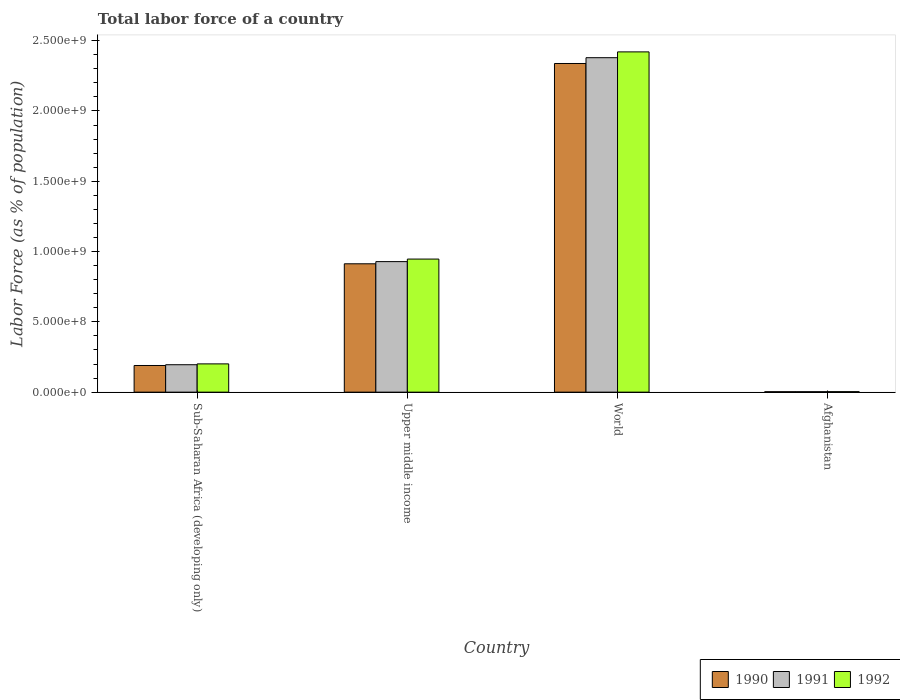How many groups of bars are there?
Make the answer very short. 4. Are the number of bars per tick equal to the number of legend labels?
Make the answer very short. Yes. Are the number of bars on each tick of the X-axis equal?
Provide a short and direct response. Yes. How many bars are there on the 2nd tick from the right?
Provide a succinct answer. 3. What is the label of the 2nd group of bars from the left?
Make the answer very short. Upper middle income. In how many cases, is the number of bars for a given country not equal to the number of legend labels?
Provide a succinct answer. 0. What is the percentage of labor force in 1991 in Upper middle income?
Provide a succinct answer. 9.28e+08. Across all countries, what is the maximum percentage of labor force in 1991?
Your response must be concise. 2.38e+09. Across all countries, what is the minimum percentage of labor force in 1992?
Offer a terse response. 3.50e+06. In which country was the percentage of labor force in 1992 minimum?
Provide a short and direct response. Afghanistan. What is the total percentage of labor force in 1991 in the graph?
Keep it short and to the point. 3.51e+09. What is the difference between the percentage of labor force in 1992 in Afghanistan and that in Upper middle income?
Your answer should be compact. -9.43e+08. What is the difference between the percentage of labor force in 1990 in Upper middle income and the percentage of labor force in 1991 in Afghanistan?
Offer a very short reply. 9.10e+08. What is the average percentage of labor force in 1990 per country?
Ensure brevity in your answer.  8.61e+08. What is the difference between the percentage of labor force of/in 1991 and percentage of labor force of/in 1992 in Upper middle income?
Your answer should be very brief. -1.81e+07. What is the ratio of the percentage of labor force in 1991 in Sub-Saharan Africa (developing only) to that in World?
Your answer should be compact. 0.08. Is the difference between the percentage of labor force in 1991 in Sub-Saharan Africa (developing only) and Upper middle income greater than the difference between the percentage of labor force in 1992 in Sub-Saharan Africa (developing only) and Upper middle income?
Provide a succinct answer. Yes. What is the difference between the highest and the second highest percentage of labor force in 1992?
Provide a succinct answer. 7.45e+08. What is the difference between the highest and the lowest percentage of labor force in 1992?
Your response must be concise. 2.42e+09. In how many countries, is the percentage of labor force in 1990 greater than the average percentage of labor force in 1990 taken over all countries?
Ensure brevity in your answer.  2. Is it the case that in every country, the sum of the percentage of labor force in 1991 and percentage of labor force in 1992 is greater than the percentage of labor force in 1990?
Provide a short and direct response. Yes. Are all the bars in the graph horizontal?
Your answer should be very brief. No. Are the values on the major ticks of Y-axis written in scientific E-notation?
Your response must be concise. Yes. Does the graph contain grids?
Offer a very short reply. No. What is the title of the graph?
Give a very brief answer. Total labor force of a country. What is the label or title of the Y-axis?
Your answer should be compact. Labor Force (as % of population). What is the Labor Force (as % of population) in 1990 in Sub-Saharan Africa (developing only)?
Your answer should be compact. 1.90e+08. What is the Labor Force (as % of population) in 1991 in Sub-Saharan Africa (developing only)?
Provide a short and direct response. 1.95e+08. What is the Labor Force (as % of population) in 1992 in Sub-Saharan Africa (developing only)?
Your response must be concise. 2.01e+08. What is the Labor Force (as % of population) in 1990 in Upper middle income?
Make the answer very short. 9.13e+08. What is the Labor Force (as % of population) in 1991 in Upper middle income?
Ensure brevity in your answer.  9.28e+08. What is the Labor Force (as % of population) in 1992 in Upper middle income?
Offer a terse response. 9.46e+08. What is the Labor Force (as % of population) of 1990 in World?
Your answer should be compact. 2.34e+09. What is the Labor Force (as % of population) in 1991 in World?
Your answer should be very brief. 2.38e+09. What is the Labor Force (as % of population) of 1992 in World?
Offer a very short reply. 2.42e+09. What is the Labor Force (as % of population) of 1990 in Afghanistan?
Keep it short and to the point. 3.08e+06. What is the Labor Force (as % of population) of 1991 in Afghanistan?
Offer a very short reply. 3.26e+06. What is the Labor Force (as % of population) of 1992 in Afghanistan?
Ensure brevity in your answer.  3.50e+06. Across all countries, what is the maximum Labor Force (as % of population) in 1990?
Your answer should be compact. 2.34e+09. Across all countries, what is the maximum Labor Force (as % of population) of 1991?
Keep it short and to the point. 2.38e+09. Across all countries, what is the maximum Labor Force (as % of population) in 1992?
Give a very brief answer. 2.42e+09. Across all countries, what is the minimum Labor Force (as % of population) of 1990?
Ensure brevity in your answer.  3.08e+06. Across all countries, what is the minimum Labor Force (as % of population) of 1991?
Make the answer very short. 3.26e+06. Across all countries, what is the minimum Labor Force (as % of population) of 1992?
Make the answer very short. 3.50e+06. What is the total Labor Force (as % of population) in 1990 in the graph?
Provide a succinct answer. 3.44e+09. What is the total Labor Force (as % of population) of 1991 in the graph?
Give a very brief answer. 3.51e+09. What is the total Labor Force (as % of population) of 1992 in the graph?
Make the answer very short. 3.57e+09. What is the difference between the Labor Force (as % of population) of 1990 in Sub-Saharan Africa (developing only) and that in Upper middle income?
Ensure brevity in your answer.  -7.23e+08. What is the difference between the Labor Force (as % of population) of 1991 in Sub-Saharan Africa (developing only) and that in Upper middle income?
Offer a very short reply. -7.33e+08. What is the difference between the Labor Force (as % of population) of 1992 in Sub-Saharan Africa (developing only) and that in Upper middle income?
Provide a short and direct response. -7.45e+08. What is the difference between the Labor Force (as % of population) in 1990 in Sub-Saharan Africa (developing only) and that in World?
Offer a terse response. -2.15e+09. What is the difference between the Labor Force (as % of population) of 1991 in Sub-Saharan Africa (developing only) and that in World?
Make the answer very short. -2.18e+09. What is the difference between the Labor Force (as % of population) of 1992 in Sub-Saharan Africa (developing only) and that in World?
Your answer should be compact. -2.22e+09. What is the difference between the Labor Force (as % of population) in 1990 in Sub-Saharan Africa (developing only) and that in Afghanistan?
Provide a short and direct response. 1.86e+08. What is the difference between the Labor Force (as % of population) in 1991 in Sub-Saharan Africa (developing only) and that in Afghanistan?
Your response must be concise. 1.92e+08. What is the difference between the Labor Force (as % of population) of 1992 in Sub-Saharan Africa (developing only) and that in Afghanistan?
Ensure brevity in your answer.  1.98e+08. What is the difference between the Labor Force (as % of population) in 1990 in Upper middle income and that in World?
Your response must be concise. -1.42e+09. What is the difference between the Labor Force (as % of population) in 1991 in Upper middle income and that in World?
Make the answer very short. -1.45e+09. What is the difference between the Labor Force (as % of population) in 1992 in Upper middle income and that in World?
Keep it short and to the point. -1.47e+09. What is the difference between the Labor Force (as % of population) of 1990 in Upper middle income and that in Afghanistan?
Provide a succinct answer. 9.10e+08. What is the difference between the Labor Force (as % of population) in 1991 in Upper middle income and that in Afghanistan?
Give a very brief answer. 9.25e+08. What is the difference between the Labor Force (as % of population) of 1992 in Upper middle income and that in Afghanistan?
Your answer should be compact. 9.43e+08. What is the difference between the Labor Force (as % of population) of 1990 in World and that in Afghanistan?
Provide a short and direct response. 2.33e+09. What is the difference between the Labor Force (as % of population) of 1991 in World and that in Afghanistan?
Ensure brevity in your answer.  2.38e+09. What is the difference between the Labor Force (as % of population) in 1992 in World and that in Afghanistan?
Make the answer very short. 2.42e+09. What is the difference between the Labor Force (as % of population) in 1990 in Sub-Saharan Africa (developing only) and the Labor Force (as % of population) in 1991 in Upper middle income?
Your answer should be very brief. -7.39e+08. What is the difference between the Labor Force (as % of population) in 1990 in Sub-Saharan Africa (developing only) and the Labor Force (as % of population) in 1992 in Upper middle income?
Provide a succinct answer. -7.57e+08. What is the difference between the Labor Force (as % of population) in 1991 in Sub-Saharan Africa (developing only) and the Labor Force (as % of population) in 1992 in Upper middle income?
Give a very brief answer. -7.51e+08. What is the difference between the Labor Force (as % of population) of 1990 in Sub-Saharan Africa (developing only) and the Labor Force (as % of population) of 1991 in World?
Ensure brevity in your answer.  -2.19e+09. What is the difference between the Labor Force (as % of population) of 1990 in Sub-Saharan Africa (developing only) and the Labor Force (as % of population) of 1992 in World?
Ensure brevity in your answer.  -2.23e+09. What is the difference between the Labor Force (as % of population) of 1991 in Sub-Saharan Africa (developing only) and the Labor Force (as % of population) of 1992 in World?
Your answer should be compact. -2.23e+09. What is the difference between the Labor Force (as % of population) in 1990 in Sub-Saharan Africa (developing only) and the Labor Force (as % of population) in 1991 in Afghanistan?
Your answer should be very brief. 1.86e+08. What is the difference between the Labor Force (as % of population) of 1990 in Sub-Saharan Africa (developing only) and the Labor Force (as % of population) of 1992 in Afghanistan?
Your response must be concise. 1.86e+08. What is the difference between the Labor Force (as % of population) in 1991 in Sub-Saharan Africa (developing only) and the Labor Force (as % of population) in 1992 in Afghanistan?
Offer a very short reply. 1.92e+08. What is the difference between the Labor Force (as % of population) of 1990 in Upper middle income and the Labor Force (as % of population) of 1991 in World?
Make the answer very short. -1.47e+09. What is the difference between the Labor Force (as % of population) of 1990 in Upper middle income and the Labor Force (as % of population) of 1992 in World?
Provide a short and direct response. -1.51e+09. What is the difference between the Labor Force (as % of population) of 1991 in Upper middle income and the Labor Force (as % of population) of 1992 in World?
Make the answer very short. -1.49e+09. What is the difference between the Labor Force (as % of population) of 1990 in Upper middle income and the Labor Force (as % of population) of 1991 in Afghanistan?
Ensure brevity in your answer.  9.10e+08. What is the difference between the Labor Force (as % of population) of 1990 in Upper middle income and the Labor Force (as % of population) of 1992 in Afghanistan?
Your answer should be compact. 9.09e+08. What is the difference between the Labor Force (as % of population) of 1991 in Upper middle income and the Labor Force (as % of population) of 1992 in Afghanistan?
Give a very brief answer. 9.25e+08. What is the difference between the Labor Force (as % of population) in 1990 in World and the Labor Force (as % of population) in 1991 in Afghanistan?
Ensure brevity in your answer.  2.33e+09. What is the difference between the Labor Force (as % of population) in 1990 in World and the Labor Force (as % of population) in 1992 in Afghanistan?
Provide a succinct answer. 2.33e+09. What is the difference between the Labor Force (as % of population) of 1991 in World and the Labor Force (as % of population) of 1992 in Afghanistan?
Your answer should be compact. 2.38e+09. What is the average Labor Force (as % of population) in 1990 per country?
Offer a very short reply. 8.61e+08. What is the average Labor Force (as % of population) of 1991 per country?
Keep it short and to the point. 8.76e+08. What is the average Labor Force (as % of population) of 1992 per country?
Keep it short and to the point. 8.93e+08. What is the difference between the Labor Force (as % of population) of 1990 and Labor Force (as % of population) of 1991 in Sub-Saharan Africa (developing only)?
Make the answer very short. -5.49e+06. What is the difference between the Labor Force (as % of population) of 1990 and Labor Force (as % of population) of 1992 in Sub-Saharan Africa (developing only)?
Ensure brevity in your answer.  -1.15e+07. What is the difference between the Labor Force (as % of population) in 1991 and Labor Force (as % of population) in 1992 in Sub-Saharan Africa (developing only)?
Offer a very short reply. -6.01e+06. What is the difference between the Labor Force (as % of population) in 1990 and Labor Force (as % of population) in 1991 in Upper middle income?
Ensure brevity in your answer.  -1.55e+07. What is the difference between the Labor Force (as % of population) of 1990 and Labor Force (as % of population) of 1992 in Upper middle income?
Your response must be concise. -3.35e+07. What is the difference between the Labor Force (as % of population) in 1991 and Labor Force (as % of population) in 1992 in Upper middle income?
Make the answer very short. -1.81e+07. What is the difference between the Labor Force (as % of population) of 1990 and Labor Force (as % of population) of 1991 in World?
Keep it short and to the point. -4.13e+07. What is the difference between the Labor Force (as % of population) in 1990 and Labor Force (as % of population) in 1992 in World?
Your answer should be very brief. -8.26e+07. What is the difference between the Labor Force (as % of population) of 1991 and Labor Force (as % of population) of 1992 in World?
Your response must be concise. -4.13e+07. What is the difference between the Labor Force (as % of population) in 1990 and Labor Force (as % of population) in 1991 in Afghanistan?
Offer a terse response. -1.80e+05. What is the difference between the Labor Force (as % of population) of 1990 and Labor Force (as % of population) of 1992 in Afghanistan?
Offer a very short reply. -4.13e+05. What is the difference between the Labor Force (as % of population) of 1991 and Labor Force (as % of population) of 1992 in Afghanistan?
Provide a short and direct response. -2.33e+05. What is the ratio of the Labor Force (as % of population) in 1990 in Sub-Saharan Africa (developing only) to that in Upper middle income?
Your answer should be compact. 0.21. What is the ratio of the Labor Force (as % of population) in 1991 in Sub-Saharan Africa (developing only) to that in Upper middle income?
Your response must be concise. 0.21. What is the ratio of the Labor Force (as % of population) of 1992 in Sub-Saharan Africa (developing only) to that in Upper middle income?
Ensure brevity in your answer.  0.21. What is the ratio of the Labor Force (as % of population) in 1990 in Sub-Saharan Africa (developing only) to that in World?
Your answer should be very brief. 0.08. What is the ratio of the Labor Force (as % of population) in 1991 in Sub-Saharan Africa (developing only) to that in World?
Give a very brief answer. 0.08. What is the ratio of the Labor Force (as % of population) of 1992 in Sub-Saharan Africa (developing only) to that in World?
Provide a short and direct response. 0.08. What is the ratio of the Labor Force (as % of population) of 1990 in Sub-Saharan Africa (developing only) to that in Afghanistan?
Ensure brevity in your answer.  61.48. What is the ratio of the Labor Force (as % of population) in 1991 in Sub-Saharan Africa (developing only) to that in Afghanistan?
Make the answer very short. 59.77. What is the ratio of the Labor Force (as % of population) in 1992 in Sub-Saharan Africa (developing only) to that in Afghanistan?
Your answer should be compact. 57.51. What is the ratio of the Labor Force (as % of population) of 1990 in Upper middle income to that in World?
Offer a terse response. 0.39. What is the ratio of the Labor Force (as % of population) in 1991 in Upper middle income to that in World?
Offer a very short reply. 0.39. What is the ratio of the Labor Force (as % of population) in 1992 in Upper middle income to that in World?
Provide a succinct answer. 0.39. What is the ratio of the Labor Force (as % of population) in 1990 in Upper middle income to that in Afghanistan?
Ensure brevity in your answer.  296.08. What is the ratio of the Labor Force (as % of population) of 1991 in Upper middle income to that in Afghanistan?
Keep it short and to the point. 284.49. What is the ratio of the Labor Force (as % of population) in 1992 in Upper middle income to that in Afghanistan?
Your answer should be compact. 270.69. What is the ratio of the Labor Force (as % of population) in 1990 in World to that in Afghanistan?
Offer a very short reply. 758.09. What is the ratio of the Labor Force (as % of population) in 1991 in World to that in Afghanistan?
Offer a very short reply. 728.92. What is the ratio of the Labor Force (as % of population) in 1992 in World to that in Afghanistan?
Provide a succinct answer. 692.14. What is the difference between the highest and the second highest Labor Force (as % of population) of 1990?
Make the answer very short. 1.42e+09. What is the difference between the highest and the second highest Labor Force (as % of population) in 1991?
Ensure brevity in your answer.  1.45e+09. What is the difference between the highest and the second highest Labor Force (as % of population) in 1992?
Your answer should be very brief. 1.47e+09. What is the difference between the highest and the lowest Labor Force (as % of population) of 1990?
Keep it short and to the point. 2.33e+09. What is the difference between the highest and the lowest Labor Force (as % of population) in 1991?
Provide a succinct answer. 2.38e+09. What is the difference between the highest and the lowest Labor Force (as % of population) in 1992?
Your answer should be compact. 2.42e+09. 